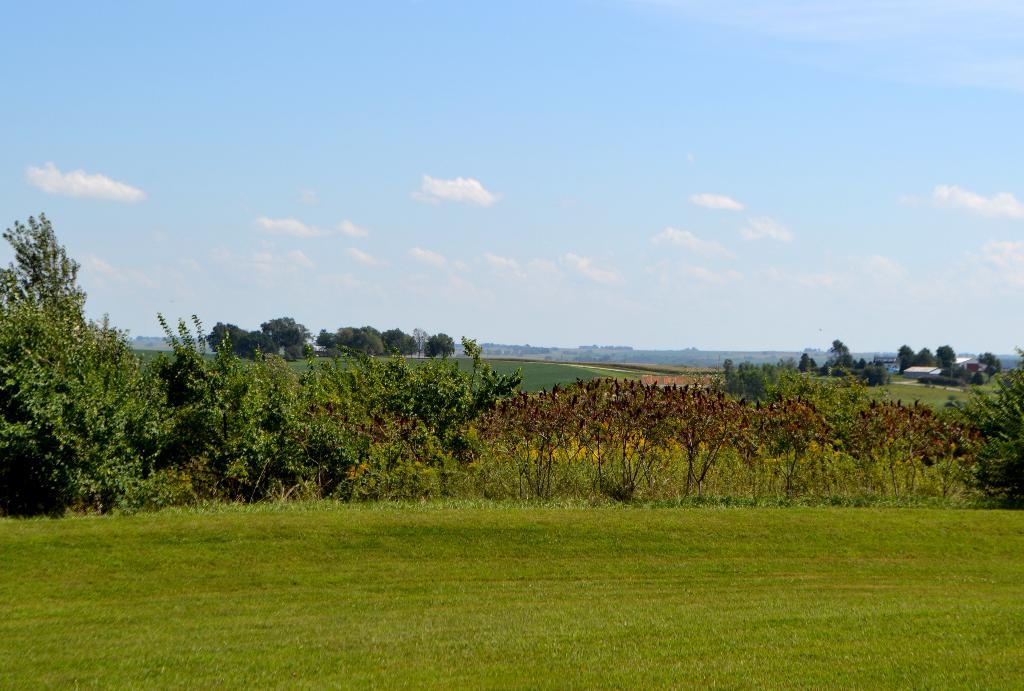What type of vegetation is present in the image? There are trees and grass in the image. What type of structure can be seen in the image? There is a building in the image. What natural feature is visible in the image? There are mountains in the image. What part of the natural environment is visible in the image? The sky is visible in the image. What type of jeans is the baby girl wearing in the image? There is no baby girl or jeans present in the image. What type of girl is depicted in the image? There is no girl depicted in the image; the main elements are trees, grass, a building, mountains, and the sky. 